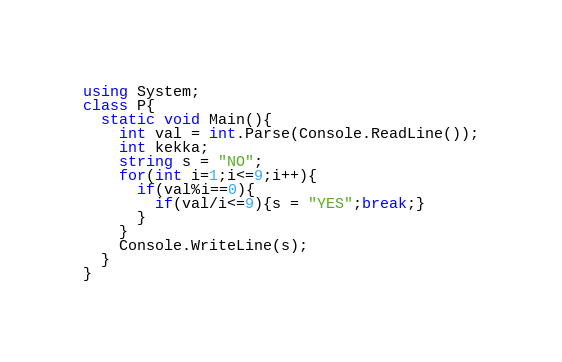<code> <loc_0><loc_0><loc_500><loc_500><_C#_>using System;
class P{
  static void Main(){
    int val = int.Parse(Console.ReadLine());
    int kekka;
    string s = "NO";
    for(int i=1;i<=9;i++){
      if(val%i==0){
        if(val/i<=9){s = "YES";break;}
      }
    }
    Console.WriteLine(s);
  }
}</code> 